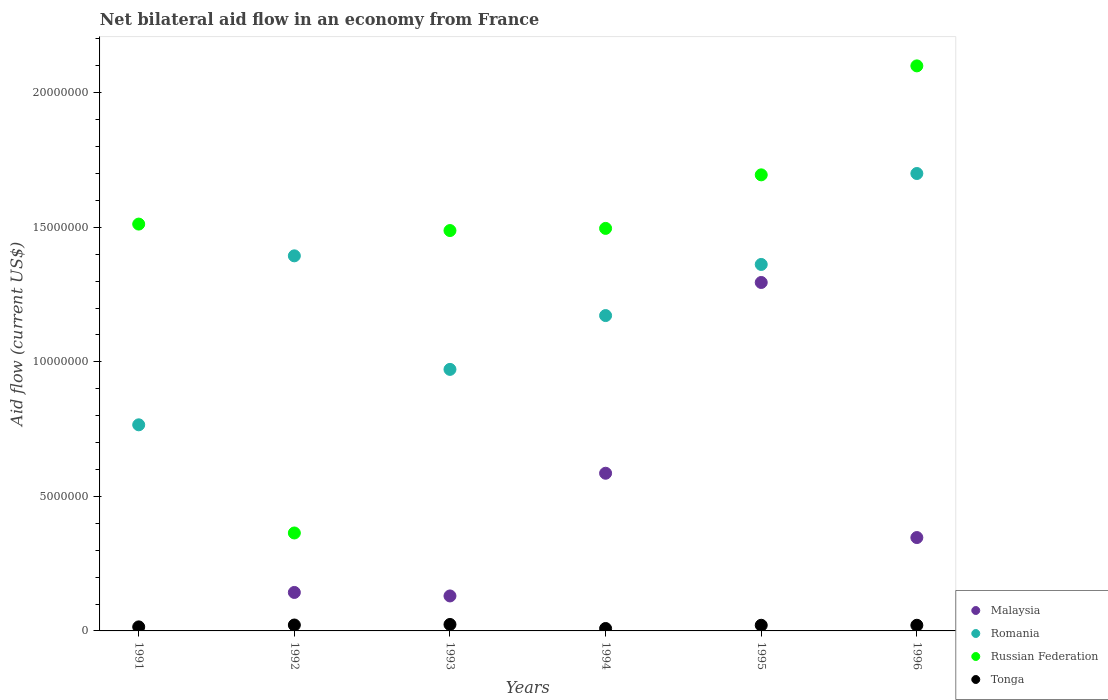Is the number of dotlines equal to the number of legend labels?
Make the answer very short. No. What is the net bilateral aid flow in Malaysia in 1996?
Provide a short and direct response. 3.47e+06. Across all years, what is the maximum net bilateral aid flow in Russian Federation?
Provide a succinct answer. 2.10e+07. Across all years, what is the minimum net bilateral aid flow in Russian Federation?
Keep it short and to the point. 3.64e+06. What is the total net bilateral aid flow in Romania in the graph?
Your answer should be very brief. 7.37e+07. What is the difference between the net bilateral aid flow in Russian Federation in 1991 and the net bilateral aid flow in Tonga in 1996?
Your answer should be very brief. 1.49e+07. What is the average net bilateral aid flow in Russian Federation per year?
Offer a very short reply. 1.44e+07. In the year 1996, what is the difference between the net bilateral aid flow in Russian Federation and net bilateral aid flow in Malaysia?
Your answer should be very brief. 1.75e+07. In how many years, is the net bilateral aid flow in Romania greater than 16000000 US$?
Provide a short and direct response. 1. What is the ratio of the net bilateral aid flow in Russian Federation in 1994 to that in 1995?
Give a very brief answer. 0.88. Is the difference between the net bilateral aid flow in Russian Federation in 1993 and 1994 greater than the difference between the net bilateral aid flow in Malaysia in 1993 and 1994?
Make the answer very short. Yes. In how many years, is the net bilateral aid flow in Malaysia greater than the average net bilateral aid flow in Malaysia taken over all years?
Keep it short and to the point. 2. Is the sum of the net bilateral aid flow in Tonga in 1995 and 1996 greater than the maximum net bilateral aid flow in Malaysia across all years?
Your answer should be very brief. No. Is it the case that in every year, the sum of the net bilateral aid flow in Tonga and net bilateral aid flow in Malaysia  is greater than the net bilateral aid flow in Russian Federation?
Give a very brief answer. No. Does the net bilateral aid flow in Malaysia monotonically increase over the years?
Your answer should be compact. No. Is the net bilateral aid flow in Romania strictly greater than the net bilateral aid flow in Malaysia over the years?
Your answer should be compact. Yes. Is the net bilateral aid flow in Russian Federation strictly less than the net bilateral aid flow in Malaysia over the years?
Your answer should be compact. No. What is the difference between two consecutive major ticks on the Y-axis?
Offer a very short reply. 5.00e+06. Are the values on the major ticks of Y-axis written in scientific E-notation?
Ensure brevity in your answer.  No. Does the graph contain any zero values?
Your answer should be very brief. Yes. How many legend labels are there?
Give a very brief answer. 4. What is the title of the graph?
Your answer should be compact. Net bilateral aid flow in an economy from France. What is the label or title of the Y-axis?
Offer a terse response. Aid flow (current US$). What is the Aid flow (current US$) in Romania in 1991?
Provide a succinct answer. 7.66e+06. What is the Aid flow (current US$) of Russian Federation in 1991?
Your response must be concise. 1.51e+07. What is the Aid flow (current US$) in Malaysia in 1992?
Your answer should be compact. 1.43e+06. What is the Aid flow (current US$) of Romania in 1992?
Your response must be concise. 1.39e+07. What is the Aid flow (current US$) of Russian Federation in 1992?
Provide a succinct answer. 3.64e+06. What is the Aid flow (current US$) in Malaysia in 1993?
Provide a succinct answer. 1.30e+06. What is the Aid flow (current US$) of Romania in 1993?
Offer a terse response. 9.72e+06. What is the Aid flow (current US$) of Russian Federation in 1993?
Offer a very short reply. 1.49e+07. What is the Aid flow (current US$) of Malaysia in 1994?
Ensure brevity in your answer.  5.86e+06. What is the Aid flow (current US$) in Romania in 1994?
Your answer should be very brief. 1.17e+07. What is the Aid flow (current US$) in Russian Federation in 1994?
Your response must be concise. 1.50e+07. What is the Aid flow (current US$) of Tonga in 1994?
Your response must be concise. 9.00e+04. What is the Aid flow (current US$) in Malaysia in 1995?
Keep it short and to the point. 1.30e+07. What is the Aid flow (current US$) in Romania in 1995?
Provide a succinct answer. 1.36e+07. What is the Aid flow (current US$) in Russian Federation in 1995?
Your answer should be very brief. 1.70e+07. What is the Aid flow (current US$) of Malaysia in 1996?
Offer a very short reply. 3.47e+06. What is the Aid flow (current US$) of Romania in 1996?
Your answer should be very brief. 1.70e+07. What is the Aid flow (current US$) of Russian Federation in 1996?
Offer a terse response. 2.10e+07. What is the Aid flow (current US$) of Tonga in 1996?
Your answer should be very brief. 2.10e+05. Across all years, what is the maximum Aid flow (current US$) in Malaysia?
Offer a very short reply. 1.30e+07. Across all years, what is the maximum Aid flow (current US$) of Romania?
Your answer should be very brief. 1.70e+07. Across all years, what is the maximum Aid flow (current US$) in Russian Federation?
Keep it short and to the point. 2.10e+07. Across all years, what is the minimum Aid flow (current US$) in Romania?
Offer a terse response. 7.66e+06. Across all years, what is the minimum Aid flow (current US$) in Russian Federation?
Give a very brief answer. 3.64e+06. What is the total Aid flow (current US$) of Malaysia in the graph?
Offer a terse response. 2.50e+07. What is the total Aid flow (current US$) of Romania in the graph?
Make the answer very short. 7.37e+07. What is the total Aid flow (current US$) in Russian Federation in the graph?
Offer a very short reply. 8.66e+07. What is the total Aid flow (current US$) in Tonga in the graph?
Ensure brevity in your answer.  1.12e+06. What is the difference between the Aid flow (current US$) of Romania in 1991 and that in 1992?
Your answer should be very brief. -6.28e+06. What is the difference between the Aid flow (current US$) in Russian Federation in 1991 and that in 1992?
Your answer should be very brief. 1.15e+07. What is the difference between the Aid flow (current US$) in Tonga in 1991 and that in 1992?
Ensure brevity in your answer.  -7.00e+04. What is the difference between the Aid flow (current US$) in Romania in 1991 and that in 1993?
Offer a terse response. -2.06e+06. What is the difference between the Aid flow (current US$) of Russian Federation in 1991 and that in 1993?
Offer a terse response. 2.40e+05. What is the difference between the Aid flow (current US$) of Tonga in 1991 and that in 1993?
Provide a short and direct response. -9.00e+04. What is the difference between the Aid flow (current US$) of Romania in 1991 and that in 1994?
Ensure brevity in your answer.  -4.06e+06. What is the difference between the Aid flow (current US$) in Romania in 1991 and that in 1995?
Your answer should be compact. -5.96e+06. What is the difference between the Aid flow (current US$) in Russian Federation in 1991 and that in 1995?
Keep it short and to the point. -1.83e+06. What is the difference between the Aid flow (current US$) of Romania in 1991 and that in 1996?
Make the answer very short. -9.34e+06. What is the difference between the Aid flow (current US$) of Russian Federation in 1991 and that in 1996?
Make the answer very short. -5.88e+06. What is the difference between the Aid flow (current US$) of Malaysia in 1992 and that in 1993?
Your response must be concise. 1.30e+05. What is the difference between the Aid flow (current US$) in Romania in 1992 and that in 1993?
Provide a succinct answer. 4.22e+06. What is the difference between the Aid flow (current US$) in Russian Federation in 1992 and that in 1993?
Ensure brevity in your answer.  -1.12e+07. What is the difference between the Aid flow (current US$) of Malaysia in 1992 and that in 1994?
Provide a succinct answer. -4.43e+06. What is the difference between the Aid flow (current US$) in Romania in 1992 and that in 1994?
Your response must be concise. 2.22e+06. What is the difference between the Aid flow (current US$) in Russian Federation in 1992 and that in 1994?
Provide a succinct answer. -1.13e+07. What is the difference between the Aid flow (current US$) in Tonga in 1992 and that in 1994?
Offer a very short reply. 1.30e+05. What is the difference between the Aid flow (current US$) of Malaysia in 1992 and that in 1995?
Make the answer very short. -1.15e+07. What is the difference between the Aid flow (current US$) in Russian Federation in 1992 and that in 1995?
Your answer should be very brief. -1.33e+07. What is the difference between the Aid flow (current US$) in Malaysia in 1992 and that in 1996?
Provide a short and direct response. -2.04e+06. What is the difference between the Aid flow (current US$) in Romania in 1992 and that in 1996?
Give a very brief answer. -3.06e+06. What is the difference between the Aid flow (current US$) in Russian Federation in 1992 and that in 1996?
Keep it short and to the point. -1.74e+07. What is the difference between the Aid flow (current US$) in Tonga in 1992 and that in 1996?
Your answer should be very brief. 10000. What is the difference between the Aid flow (current US$) of Malaysia in 1993 and that in 1994?
Your answer should be very brief. -4.56e+06. What is the difference between the Aid flow (current US$) in Russian Federation in 1993 and that in 1994?
Give a very brief answer. -8.00e+04. What is the difference between the Aid flow (current US$) in Malaysia in 1993 and that in 1995?
Keep it short and to the point. -1.16e+07. What is the difference between the Aid flow (current US$) of Romania in 1993 and that in 1995?
Provide a short and direct response. -3.90e+06. What is the difference between the Aid flow (current US$) in Russian Federation in 1993 and that in 1995?
Give a very brief answer. -2.07e+06. What is the difference between the Aid flow (current US$) of Tonga in 1993 and that in 1995?
Offer a terse response. 3.00e+04. What is the difference between the Aid flow (current US$) of Malaysia in 1993 and that in 1996?
Provide a succinct answer. -2.17e+06. What is the difference between the Aid flow (current US$) in Romania in 1993 and that in 1996?
Ensure brevity in your answer.  -7.28e+06. What is the difference between the Aid flow (current US$) in Russian Federation in 1993 and that in 1996?
Your answer should be very brief. -6.12e+06. What is the difference between the Aid flow (current US$) of Tonga in 1993 and that in 1996?
Your answer should be very brief. 3.00e+04. What is the difference between the Aid flow (current US$) in Malaysia in 1994 and that in 1995?
Offer a very short reply. -7.09e+06. What is the difference between the Aid flow (current US$) in Romania in 1994 and that in 1995?
Give a very brief answer. -1.90e+06. What is the difference between the Aid flow (current US$) of Russian Federation in 1994 and that in 1995?
Ensure brevity in your answer.  -1.99e+06. What is the difference between the Aid flow (current US$) in Tonga in 1994 and that in 1995?
Give a very brief answer. -1.20e+05. What is the difference between the Aid flow (current US$) in Malaysia in 1994 and that in 1996?
Give a very brief answer. 2.39e+06. What is the difference between the Aid flow (current US$) in Romania in 1994 and that in 1996?
Ensure brevity in your answer.  -5.28e+06. What is the difference between the Aid flow (current US$) of Russian Federation in 1994 and that in 1996?
Offer a very short reply. -6.04e+06. What is the difference between the Aid flow (current US$) of Tonga in 1994 and that in 1996?
Your response must be concise. -1.20e+05. What is the difference between the Aid flow (current US$) of Malaysia in 1995 and that in 1996?
Offer a very short reply. 9.48e+06. What is the difference between the Aid flow (current US$) of Romania in 1995 and that in 1996?
Your answer should be compact. -3.38e+06. What is the difference between the Aid flow (current US$) of Russian Federation in 1995 and that in 1996?
Give a very brief answer. -4.05e+06. What is the difference between the Aid flow (current US$) in Romania in 1991 and the Aid flow (current US$) in Russian Federation in 1992?
Ensure brevity in your answer.  4.02e+06. What is the difference between the Aid flow (current US$) in Romania in 1991 and the Aid flow (current US$) in Tonga in 1992?
Ensure brevity in your answer.  7.44e+06. What is the difference between the Aid flow (current US$) of Russian Federation in 1991 and the Aid flow (current US$) of Tonga in 1992?
Keep it short and to the point. 1.49e+07. What is the difference between the Aid flow (current US$) of Romania in 1991 and the Aid flow (current US$) of Russian Federation in 1993?
Offer a very short reply. -7.22e+06. What is the difference between the Aid flow (current US$) in Romania in 1991 and the Aid flow (current US$) in Tonga in 1993?
Ensure brevity in your answer.  7.42e+06. What is the difference between the Aid flow (current US$) in Russian Federation in 1991 and the Aid flow (current US$) in Tonga in 1993?
Provide a succinct answer. 1.49e+07. What is the difference between the Aid flow (current US$) of Romania in 1991 and the Aid flow (current US$) of Russian Federation in 1994?
Offer a terse response. -7.30e+06. What is the difference between the Aid flow (current US$) in Romania in 1991 and the Aid flow (current US$) in Tonga in 1994?
Provide a short and direct response. 7.57e+06. What is the difference between the Aid flow (current US$) of Russian Federation in 1991 and the Aid flow (current US$) of Tonga in 1994?
Give a very brief answer. 1.50e+07. What is the difference between the Aid flow (current US$) of Romania in 1991 and the Aid flow (current US$) of Russian Federation in 1995?
Keep it short and to the point. -9.29e+06. What is the difference between the Aid flow (current US$) in Romania in 1991 and the Aid flow (current US$) in Tonga in 1995?
Ensure brevity in your answer.  7.45e+06. What is the difference between the Aid flow (current US$) in Russian Federation in 1991 and the Aid flow (current US$) in Tonga in 1995?
Your answer should be compact. 1.49e+07. What is the difference between the Aid flow (current US$) of Romania in 1991 and the Aid flow (current US$) of Russian Federation in 1996?
Offer a very short reply. -1.33e+07. What is the difference between the Aid flow (current US$) of Romania in 1991 and the Aid flow (current US$) of Tonga in 1996?
Offer a terse response. 7.45e+06. What is the difference between the Aid flow (current US$) of Russian Federation in 1991 and the Aid flow (current US$) of Tonga in 1996?
Offer a terse response. 1.49e+07. What is the difference between the Aid flow (current US$) in Malaysia in 1992 and the Aid flow (current US$) in Romania in 1993?
Your response must be concise. -8.29e+06. What is the difference between the Aid flow (current US$) of Malaysia in 1992 and the Aid flow (current US$) of Russian Federation in 1993?
Offer a very short reply. -1.34e+07. What is the difference between the Aid flow (current US$) of Malaysia in 1992 and the Aid flow (current US$) of Tonga in 1993?
Provide a short and direct response. 1.19e+06. What is the difference between the Aid flow (current US$) in Romania in 1992 and the Aid flow (current US$) in Russian Federation in 1993?
Provide a short and direct response. -9.40e+05. What is the difference between the Aid flow (current US$) in Romania in 1992 and the Aid flow (current US$) in Tonga in 1993?
Make the answer very short. 1.37e+07. What is the difference between the Aid flow (current US$) in Russian Federation in 1992 and the Aid flow (current US$) in Tonga in 1993?
Your answer should be compact. 3.40e+06. What is the difference between the Aid flow (current US$) in Malaysia in 1992 and the Aid flow (current US$) in Romania in 1994?
Provide a short and direct response. -1.03e+07. What is the difference between the Aid flow (current US$) in Malaysia in 1992 and the Aid flow (current US$) in Russian Federation in 1994?
Provide a short and direct response. -1.35e+07. What is the difference between the Aid flow (current US$) of Malaysia in 1992 and the Aid flow (current US$) of Tonga in 1994?
Your answer should be very brief. 1.34e+06. What is the difference between the Aid flow (current US$) of Romania in 1992 and the Aid flow (current US$) of Russian Federation in 1994?
Give a very brief answer. -1.02e+06. What is the difference between the Aid flow (current US$) of Romania in 1992 and the Aid flow (current US$) of Tonga in 1994?
Your response must be concise. 1.38e+07. What is the difference between the Aid flow (current US$) in Russian Federation in 1992 and the Aid flow (current US$) in Tonga in 1994?
Give a very brief answer. 3.55e+06. What is the difference between the Aid flow (current US$) of Malaysia in 1992 and the Aid flow (current US$) of Romania in 1995?
Make the answer very short. -1.22e+07. What is the difference between the Aid flow (current US$) in Malaysia in 1992 and the Aid flow (current US$) in Russian Federation in 1995?
Your answer should be very brief. -1.55e+07. What is the difference between the Aid flow (current US$) of Malaysia in 1992 and the Aid flow (current US$) of Tonga in 1995?
Provide a succinct answer. 1.22e+06. What is the difference between the Aid flow (current US$) of Romania in 1992 and the Aid flow (current US$) of Russian Federation in 1995?
Provide a short and direct response. -3.01e+06. What is the difference between the Aid flow (current US$) in Romania in 1992 and the Aid flow (current US$) in Tonga in 1995?
Your answer should be very brief. 1.37e+07. What is the difference between the Aid flow (current US$) of Russian Federation in 1992 and the Aid flow (current US$) of Tonga in 1995?
Your response must be concise. 3.43e+06. What is the difference between the Aid flow (current US$) of Malaysia in 1992 and the Aid flow (current US$) of Romania in 1996?
Your answer should be compact. -1.56e+07. What is the difference between the Aid flow (current US$) in Malaysia in 1992 and the Aid flow (current US$) in Russian Federation in 1996?
Keep it short and to the point. -1.96e+07. What is the difference between the Aid flow (current US$) in Malaysia in 1992 and the Aid flow (current US$) in Tonga in 1996?
Your response must be concise. 1.22e+06. What is the difference between the Aid flow (current US$) in Romania in 1992 and the Aid flow (current US$) in Russian Federation in 1996?
Offer a very short reply. -7.06e+06. What is the difference between the Aid flow (current US$) of Romania in 1992 and the Aid flow (current US$) of Tonga in 1996?
Give a very brief answer. 1.37e+07. What is the difference between the Aid flow (current US$) of Russian Federation in 1992 and the Aid flow (current US$) of Tonga in 1996?
Provide a short and direct response. 3.43e+06. What is the difference between the Aid flow (current US$) of Malaysia in 1993 and the Aid flow (current US$) of Romania in 1994?
Ensure brevity in your answer.  -1.04e+07. What is the difference between the Aid flow (current US$) in Malaysia in 1993 and the Aid flow (current US$) in Russian Federation in 1994?
Offer a very short reply. -1.37e+07. What is the difference between the Aid flow (current US$) in Malaysia in 1993 and the Aid flow (current US$) in Tonga in 1994?
Keep it short and to the point. 1.21e+06. What is the difference between the Aid flow (current US$) in Romania in 1993 and the Aid flow (current US$) in Russian Federation in 1994?
Your response must be concise. -5.24e+06. What is the difference between the Aid flow (current US$) of Romania in 1993 and the Aid flow (current US$) of Tonga in 1994?
Keep it short and to the point. 9.63e+06. What is the difference between the Aid flow (current US$) in Russian Federation in 1993 and the Aid flow (current US$) in Tonga in 1994?
Provide a short and direct response. 1.48e+07. What is the difference between the Aid flow (current US$) of Malaysia in 1993 and the Aid flow (current US$) of Romania in 1995?
Offer a terse response. -1.23e+07. What is the difference between the Aid flow (current US$) in Malaysia in 1993 and the Aid flow (current US$) in Russian Federation in 1995?
Your answer should be very brief. -1.56e+07. What is the difference between the Aid flow (current US$) in Malaysia in 1993 and the Aid flow (current US$) in Tonga in 1995?
Your response must be concise. 1.09e+06. What is the difference between the Aid flow (current US$) of Romania in 1993 and the Aid flow (current US$) of Russian Federation in 1995?
Offer a terse response. -7.23e+06. What is the difference between the Aid flow (current US$) in Romania in 1993 and the Aid flow (current US$) in Tonga in 1995?
Give a very brief answer. 9.51e+06. What is the difference between the Aid flow (current US$) in Russian Federation in 1993 and the Aid flow (current US$) in Tonga in 1995?
Your answer should be very brief. 1.47e+07. What is the difference between the Aid flow (current US$) of Malaysia in 1993 and the Aid flow (current US$) of Romania in 1996?
Your answer should be compact. -1.57e+07. What is the difference between the Aid flow (current US$) in Malaysia in 1993 and the Aid flow (current US$) in Russian Federation in 1996?
Your answer should be very brief. -1.97e+07. What is the difference between the Aid flow (current US$) in Malaysia in 1993 and the Aid flow (current US$) in Tonga in 1996?
Offer a terse response. 1.09e+06. What is the difference between the Aid flow (current US$) of Romania in 1993 and the Aid flow (current US$) of Russian Federation in 1996?
Your answer should be compact. -1.13e+07. What is the difference between the Aid flow (current US$) of Romania in 1993 and the Aid flow (current US$) of Tonga in 1996?
Ensure brevity in your answer.  9.51e+06. What is the difference between the Aid flow (current US$) of Russian Federation in 1993 and the Aid flow (current US$) of Tonga in 1996?
Your response must be concise. 1.47e+07. What is the difference between the Aid flow (current US$) in Malaysia in 1994 and the Aid flow (current US$) in Romania in 1995?
Ensure brevity in your answer.  -7.76e+06. What is the difference between the Aid flow (current US$) in Malaysia in 1994 and the Aid flow (current US$) in Russian Federation in 1995?
Provide a short and direct response. -1.11e+07. What is the difference between the Aid flow (current US$) in Malaysia in 1994 and the Aid flow (current US$) in Tonga in 1995?
Keep it short and to the point. 5.65e+06. What is the difference between the Aid flow (current US$) in Romania in 1994 and the Aid flow (current US$) in Russian Federation in 1995?
Your answer should be very brief. -5.23e+06. What is the difference between the Aid flow (current US$) in Romania in 1994 and the Aid flow (current US$) in Tonga in 1995?
Your answer should be very brief. 1.15e+07. What is the difference between the Aid flow (current US$) in Russian Federation in 1994 and the Aid flow (current US$) in Tonga in 1995?
Offer a terse response. 1.48e+07. What is the difference between the Aid flow (current US$) of Malaysia in 1994 and the Aid flow (current US$) of Romania in 1996?
Offer a terse response. -1.11e+07. What is the difference between the Aid flow (current US$) in Malaysia in 1994 and the Aid flow (current US$) in Russian Federation in 1996?
Your answer should be very brief. -1.51e+07. What is the difference between the Aid flow (current US$) in Malaysia in 1994 and the Aid flow (current US$) in Tonga in 1996?
Your answer should be very brief. 5.65e+06. What is the difference between the Aid flow (current US$) of Romania in 1994 and the Aid flow (current US$) of Russian Federation in 1996?
Provide a succinct answer. -9.28e+06. What is the difference between the Aid flow (current US$) in Romania in 1994 and the Aid flow (current US$) in Tonga in 1996?
Give a very brief answer. 1.15e+07. What is the difference between the Aid flow (current US$) in Russian Federation in 1994 and the Aid flow (current US$) in Tonga in 1996?
Provide a succinct answer. 1.48e+07. What is the difference between the Aid flow (current US$) of Malaysia in 1995 and the Aid flow (current US$) of Romania in 1996?
Make the answer very short. -4.05e+06. What is the difference between the Aid flow (current US$) of Malaysia in 1995 and the Aid flow (current US$) of Russian Federation in 1996?
Your response must be concise. -8.05e+06. What is the difference between the Aid flow (current US$) in Malaysia in 1995 and the Aid flow (current US$) in Tonga in 1996?
Offer a very short reply. 1.27e+07. What is the difference between the Aid flow (current US$) of Romania in 1995 and the Aid flow (current US$) of Russian Federation in 1996?
Your answer should be compact. -7.38e+06. What is the difference between the Aid flow (current US$) in Romania in 1995 and the Aid flow (current US$) in Tonga in 1996?
Keep it short and to the point. 1.34e+07. What is the difference between the Aid flow (current US$) of Russian Federation in 1995 and the Aid flow (current US$) of Tonga in 1996?
Ensure brevity in your answer.  1.67e+07. What is the average Aid flow (current US$) in Malaysia per year?
Make the answer very short. 4.17e+06. What is the average Aid flow (current US$) in Romania per year?
Your answer should be compact. 1.23e+07. What is the average Aid flow (current US$) in Russian Federation per year?
Your response must be concise. 1.44e+07. What is the average Aid flow (current US$) in Tonga per year?
Offer a terse response. 1.87e+05. In the year 1991, what is the difference between the Aid flow (current US$) of Romania and Aid flow (current US$) of Russian Federation?
Ensure brevity in your answer.  -7.46e+06. In the year 1991, what is the difference between the Aid flow (current US$) in Romania and Aid flow (current US$) in Tonga?
Provide a short and direct response. 7.51e+06. In the year 1991, what is the difference between the Aid flow (current US$) in Russian Federation and Aid flow (current US$) in Tonga?
Offer a very short reply. 1.50e+07. In the year 1992, what is the difference between the Aid flow (current US$) in Malaysia and Aid flow (current US$) in Romania?
Your answer should be compact. -1.25e+07. In the year 1992, what is the difference between the Aid flow (current US$) of Malaysia and Aid flow (current US$) of Russian Federation?
Ensure brevity in your answer.  -2.21e+06. In the year 1992, what is the difference between the Aid flow (current US$) in Malaysia and Aid flow (current US$) in Tonga?
Keep it short and to the point. 1.21e+06. In the year 1992, what is the difference between the Aid flow (current US$) in Romania and Aid flow (current US$) in Russian Federation?
Provide a short and direct response. 1.03e+07. In the year 1992, what is the difference between the Aid flow (current US$) in Romania and Aid flow (current US$) in Tonga?
Provide a short and direct response. 1.37e+07. In the year 1992, what is the difference between the Aid flow (current US$) of Russian Federation and Aid flow (current US$) of Tonga?
Offer a terse response. 3.42e+06. In the year 1993, what is the difference between the Aid flow (current US$) of Malaysia and Aid flow (current US$) of Romania?
Offer a very short reply. -8.42e+06. In the year 1993, what is the difference between the Aid flow (current US$) of Malaysia and Aid flow (current US$) of Russian Federation?
Give a very brief answer. -1.36e+07. In the year 1993, what is the difference between the Aid flow (current US$) in Malaysia and Aid flow (current US$) in Tonga?
Make the answer very short. 1.06e+06. In the year 1993, what is the difference between the Aid flow (current US$) in Romania and Aid flow (current US$) in Russian Federation?
Your response must be concise. -5.16e+06. In the year 1993, what is the difference between the Aid flow (current US$) in Romania and Aid flow (current US$) in Tonga?
Give a very brief answer. 9.48e+06. In the year 1993, what is the difference between the Aid flow (current US$) in Russian Federation and Aid flow (current US$) in Tonga?
Ensure brevity in your answer.  1.46e+07. In the year 1994, what is the difference between the Aid flow (current US$) of Malaysia and Aid flow (current US$) of Romania?
Keep it short and to the point. -5.86e+06. In the year 1994, what is the difference between the Aid flow (current US$) in Malaysia and Aid flow (current US$) in Russian Federation?
Give a very brief answer. -9.10e+06. In the year 1994, what is the difference between the Aid flow (current US$) of Malaysia and Aid flow (current US$) of Tonga?
Ensure brevity in your answer.  5.77e+06. In the year 1994, what is the difference between the Aid flow (current US$) of Romania and Aid flow (current US$) of Russian Federation?
Offer a very short reply. -3.24e+06. In the year 1994, what is the difference between the Aid flow (current US$) in Romania and Aid flow (current US$) in Tonga?
Make the answer very short. 1.16e+07. In the year 1994, what is the difference between the Aid flow (current US$) in Russian Federation and Aid flow (current US$) in Tonga?
Provide a short and direct response. 1.49e+07. In the year 1995, what is the difference between the Aid flow (current US$) of Malaysia and Aid flow (current US$) of Romania?
Offer a terse response. -6.70e+05. In the year 1995, what is the difference between the Aid flow (current US$) of Malaysia and Aid flow (current US$) of Russian Federation?
Provide a succinct answer. -4.00e+06. In the year 1995, what is the difference between the Aid flow (current US$) of Malaysia and Aid flow (current US$) of Tonga?
Give a very brief answer. 1.27e+07. In the year 1995, what is the difference between the Aid flow (current US$) of Romania and Aid flow (current US$) of Russian Federation?
Offer a terse response. -3.33e+06. In the year 1995, what is the difference between the Aid flow (current US$) of Romania and Aid flow (current US$) of Tonga?
Provide a succinct answer. 1.34e+07. In the year 1995, what is the difference between the Aid flow (current US$) in Russian Federation and Aid flow (current US$) in Tonga?
Provide a short and direct response. 1.67e+07. In the year 1996, what is the difference between the Aid flow (current US$) of Malaysia and Aid flow (current US$) of Romania?
Your answer should be compact. -1.35e+07. In the year 1996, what is the difference between the Aid flow (current US$) in Malaysia and Aid flow (current US$) in Russian Federation?
Keep it short and to the point. -1.75e+07. In the year 1996, what is the difference between the Aid flow (current US$) in Malaysia and Aid flow (current US$) in Tonga?
Your answer should be very brief. 3.26e+06. In the year 1996, what is the difference between the Aid flow (current US$) of Romania and Aid flow (current US$) of Russian Federation?
Give a very brief answer. -4.00e+06. In the year 1996, what is the difference between the Aid flow (current US$) of Romania and Aid flow (current US$) of Tonga?
Provide a short and direct response. 1.68e+07. In the year 1996, what is the difference between the Aid flow (current US$) in Russian Federation and Aid flow (current US$) in Tonga?
Provide a succinct answer. 2.08e+07. What is the ratio of the Aid flow (current US$) of Romania in 1991 to that in 1992?
Provide a succinct answer. 0.55. What is the ratio of the Aid flow (current US$) of Russian Federation in 1991 to that in 1992?
Give a very brief answer. 4.15. What is the ratio of the Aid flow (current US$) in Tonga in 1991 to that in 1992?
Offer a terse response. 0.68. What is the ratio of the Aid flow (current US$) in Romania in 1991 to that in 1993?
Provide a succinct answer. 0.79. What is the ratio of the Aid flow (current US$) in Russian Federation in 1991 to that in 1993?
Give a very brief answer. 1.02. What is the ratio of the Aid flow (current US$) in Tonga in 1991 to that in 1993?
Your answer should be compact. 0.62. What is the ratio of the Aid flow (current US$) of Romania in 1991 to that in 1994?
Make the answer very short. 0.65. What is the ratio of the Aid flow (current US$) in Russian Federation in 1991 to that in 1994?
Your answer should be very brief. 1.01. What is the ratio of the Aid flow (current US$) of Romania in 1991 to that in 1995?
Keep it short and to the point. 0.56. What is the ratio of the Aid flow (current US$) in Russian Federation in 1991 to that in 1995?
Offer a very short reply. 0.89. What is the ratio of the Aid flow (current US$) of Tonga in 1991 to that in 1995?
Your answer should be compact. 0.71. What is the ratio of the Aid flow (current US$) of Romania in 1991 to that in 1996?
Provide a succinct answer. 0.45. What is the ratio of the Aid flow (current US$) in Russian Federation in 1991 to that in 1996?
Offer a terse response. 0.72. What is the ratio of the Aid flow (current US$) in Tonga in 1991 to that in 1996?
Provide a succinct answer. 0.71. What is the ratio of the Aid flow (current US$) of Malaysia in 1992 to that in 1993?
Provide a short and direct response. 1.1. What is the ratio of the Aid flow (current US$) in Romania in 1992 to that in 1993?
Provide a short and direct response. 1.43. What is the ratio of the Aid flow (current US$) in Russian Federation in 1992 to that in 1993?
Your response must be concise. 0.24. What is the ratio of the Aid flow (current US$) of Malaysia in 1992 to that in 1994?
Provide a succinct answer. 0.24. What is the ratio of the Aid flow (current US$) of Romania in 1992 to that in 1994?
Offer a terse response. 1.19. What is the ratio of the Aid flow (current US$) in Russian Federation in 1992 to that in 1994?
Your answer should be compact. 0.24. What is the ratio of the Aid flow (current US$) in Tonga in 1992 to that in 1994?
Give a very brief answer. 2.44. What is the ratio of the Aid flow (current US$) of Malaysia in 1992 to that in 1995?
Keep it short and to the point. 0.11. What is the ratio of the Aid flow (current US$) in Romania in 1992 to that in 1995?
Offer a terse response. 1.02. What is the ratio of the Aid flow (current US$) of Russian Federation in 1992 to that in 1995?
Offer a very short reply. 0.21. What is the ratio of the Aid flow (current US$) in Tonga in 1992 to that in 1995?
Your answer should be compact. 1.05. What is the ratio of the Aid flow (current US$) in Malaysia in 1992 to that in 1996?
Your response must be concise. 0.41. What is the ratio of the Aid flow (current US$) in Romania in 1992 to that in 1996?
Give a very brief answer. 0.82. What is the ratio of the Aid flow (current US$) in Russian Federation in 1992 to that in 1996?
Your response must be concise. 0.17. What is the ratio of the Aid flow (current US$) of Tonga in 1992 to that in 1996?
Give a very brief answer. 1.05. What is the ratio of the Aid flow (current US$) of Malaysia in 1993 to that in 1994?
Make the answer very short. 0.22. What is the ratio of the Aid flow (current US$) in Romania in 1993 to that in 1994?
Your response must be concise. 0.83. What is the ratio of the Aid flow (current US$) of Tonga in 1993 to that in 1994?
Your answer should be compact. 2.67. What is the ratio of the Aid flow (current US$) in Malaysia in 1993 to that in 1995?
Your answer should be very brief. 0.1. What is the ratio of the Aid flow (current US$) of Romania in 1993 to that in 1995?
Your answer should be compact. 0.71. What is the ratio of the Aid flow (current US$) in Russian Federation in 1993 to that in 1995?
Provide a short and direct response. 0.88. What is the ratio of the Aid flow (current US$) of Malaysia in 1993 to that in 1996?
Your answer should be compact. 0.37. What is the ratio of the Aid flow (current US$) in Romania in 1993 to that in 1996?
Give a very brief answer. 0.57. What is the ratio of the Aid flow (current US$) of Russian Federation in 1993 to that in 1996?
Your response must be concise. 0.71. What is the ratio of the Aid flow (current US$) in Tonga in 1993 to that in 1996?
Provide a short and direct response. 1.14. What is the ratio of the Aid flow (current US$) in Malaysia in 1994 to that in 1995?
Offer a terse response. 0.45. What is the ratio of the Aid flow (current US$) in Romania in 1994 to that in 1995?
Provide a short and direct response. 0.86. What is the ratio of the Aid flow (current US$) in Russian Federation in 1994 to that in 1995?
Make the answer very short. 0.88. What is the ratio of the Aid flow (current US$) of Tonga in 1994 to that in 1995?
Your response must be concise. 0.43. What is the ratio of the Aid flow (current US$) of Malaysia in 1994 to that in 1996?
Provide a short and direct response. 1.69. What is the ratio of the Aid flow (current US$) in Romania in 1994 to that in 1996?
Your answer should be compact. 0.69. What is the ratio of the Aid flow (current US$) of Russian Federation in 1994 to that in 1996?
Provide a succinct answer. 0.71. What is the ratio of the Aid flow (current US$) in Tonga in 1994 to that in 1996?
Keep it short and to the point. 0.43. What is the ratio of the Aid flow (current US$) in Malaysia in 1995 to that in 1996?
Provide a succinct answer. 3.73. What is the ratio of the Aid flow (current US$) of Romania in 1995 to that in 1996?
Ensure brevity in your answer.  0.8. What is the ratio of the Aid flow (current US$) of Russian Federation in 1995 to that in 1996?
Offer a very short reply. 0.81. What is the difference between the highest and the second highest Aid flow (current US$) in Malaysia?
Keep it short and to the point. 7.09e+06. What is the difference between the highest and the second highest Aid flow (current US$) of Romania?
Offer a very short reply. 3.06e+06. What is the difference between the highest and the second highest Aid flow (current US$) in Russian Federation?
Your answer should be very brief. 4.05e+06. What is the difference between the highest and the second highest Aid flow (current US$) of Tonga?
Your response must be concise. 2.00e+04. What is the difference between the highest and the lowest Aid flow (current US$) of Malaysia?
Offer a very short reply. 1.30e+07. What is the difference between the highest and the lowest Aid flow (current US$) in Romania?
Make the answer very short. 9.34e+06. What is the difference between the highest and the lowest Aid flow (current US$) in Russian Federation?
Your answer should be very brief. 1.74e+07. What is the difference between the highest and the lowest Aid flow (current US$) of Tonga?
Offer a terse response. 1.50e+05. 